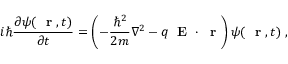<formula> <loc_0><loc_0><loc_500><loc_500>i \hbar { } \partial \psi ( r , t ) } { \partial t } = \left ( - \frac { \hbar { ^ } { 2 } } { 2 m } \nabla ^ { 2 } - q E \cdot r \right ) \psi ( r , t ) \, ,</formula> 